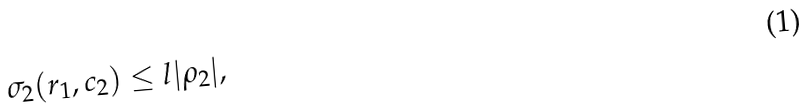Convert formula to latex. <formula><loc_0><loc_0><loc_500><loc_500>\sigma _ { 2 } ( r _ { 1 } , c _ { 2 } ) \leq l | \rho _ { 2 } | ,</formula> 